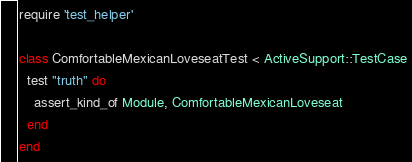<code> <loc_0><loc_0><loc_500><loc_500><_Ruby_>require 'test_helper'

class ComfortableMexicanLoveseatTest < ActiveSupport::TestCase
  test "truth" do
    assert_kind_of Module, ComfortableMexicanLoveseat
  end
end
</code> 